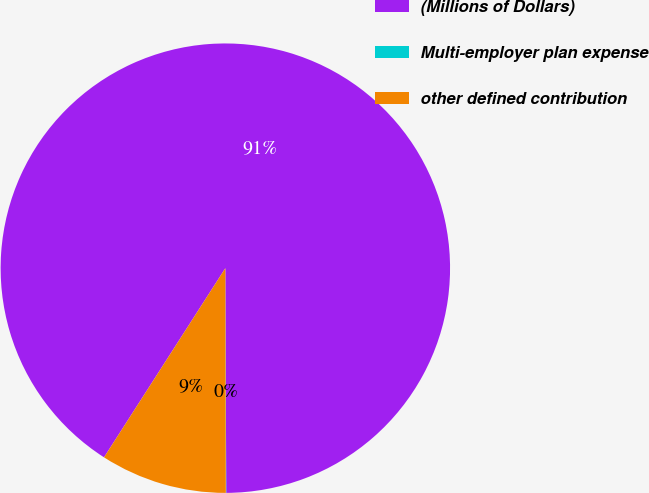Convert chart. <chart><loc_0><loc_0><loc_500><loc_500><pie_chart><fcel>(Millions of Dollars)<fcel>Multi-employer plan expense<fcel>other defined contribution<nl><fcel>90.85%<fcel>0.03%<fcel>9.11%<nl></chart> 